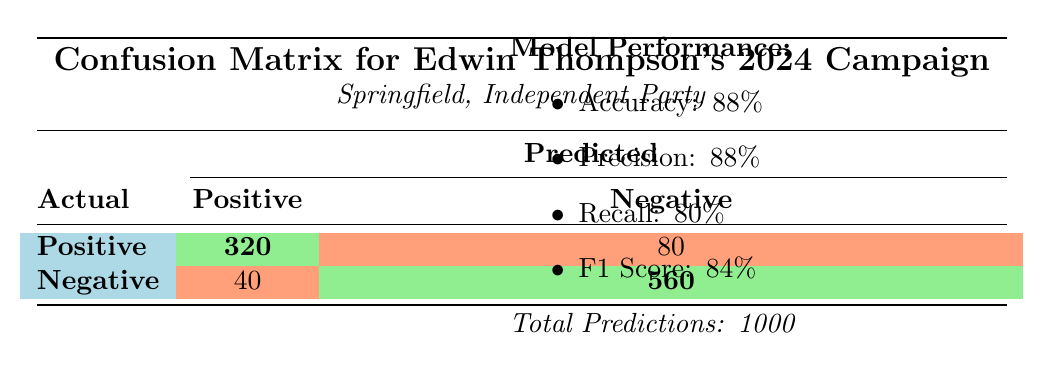What is the total number of actual positive cases? The total number of actual positive cases is the sum of predicted positive and predicted negative values for actual positives: 320 (predicted positive) + 80 (predicted negative) = 400.
Answer: 400 What is the number of true negatives? The true negatives are the actual negative cases that were also predicted as negative, which is given as 560 in the table.
Answer: 560 What is the precision of the election prediction model? The precision is provided directly in the model performance section as 88%.
Answer: 88% How many false positives were recorded? False positives are the actual negative cases that were incorrectly predicted as positive: 40. This value is shown directly in the confusion matrix.
Answer: 40 What is the sum of all positive predictions? The sum of all positive predictions consists of those predicted as positive regardless of actual outcome: 320 (true positive) + 40 (false positive) = 360.
Answer: 360 Is the recall of the model greater than the precision? The recall is 80% and the precision is 88%. Since 80% is less than 88%, the statement is false.
Answer: No What percentage of the total predictions were actual negative predictions? The actual negatives are 560 (true negatives) + 40 (false positives) = 600. To find the percentage, we calculate (600 / 1000) * 100 = 60%.
Answer: 60% What is the F1 score of Edwin's election prediction model? The F1 score is provided directly in the model performance section as 84%.
Answer: 84% What is the difference between true positives and false negatives? True positives are 320, and false negatives are the actual positives not predicted as positive, which is 80. The difference is 320 - 80 = 240.
Answer: 240 